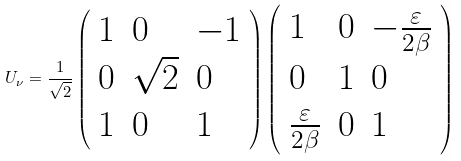<formula> <loc_0><loc_0><loc_500><loc_500>U _ { \nu } = \frac { 1 } { \sqrt { 2 } } \left ( \begin{array} { l l l } 1 & 0 & - 1 \\ 0 & \sqrt { 2 } & 0 \\ 1 & 0 & 1 \end{array} \right ) \left ( \begin{array} { l l l } 1 & 0 & - \frac { \varepsilon } { 2 \beta } \\ 0 & 1 & 0 \\ \frac { \varepsilon } { 2 \beta } & 0 & 1 \end{array} \right )</formula> 